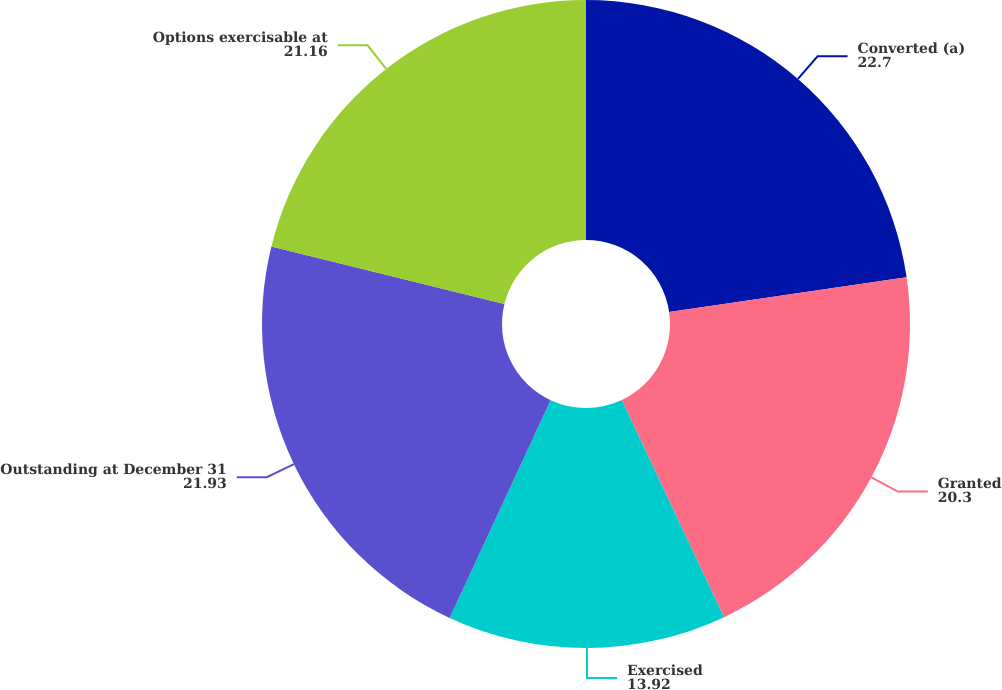Convert chart to OTSL. <chart><loc_0><loc_0><loc_500><loc_500><pie_chart><fcel>Converted (a)<fcel>Granted<fcel>Exercised<fcel>Outstanding at December 31<fcel>Options exercisable at<nl><fcel>22.7%<fcel>20.3%<fcel>13.92%<fcel>21.93%<fcel>21.16%<nl></chart> 